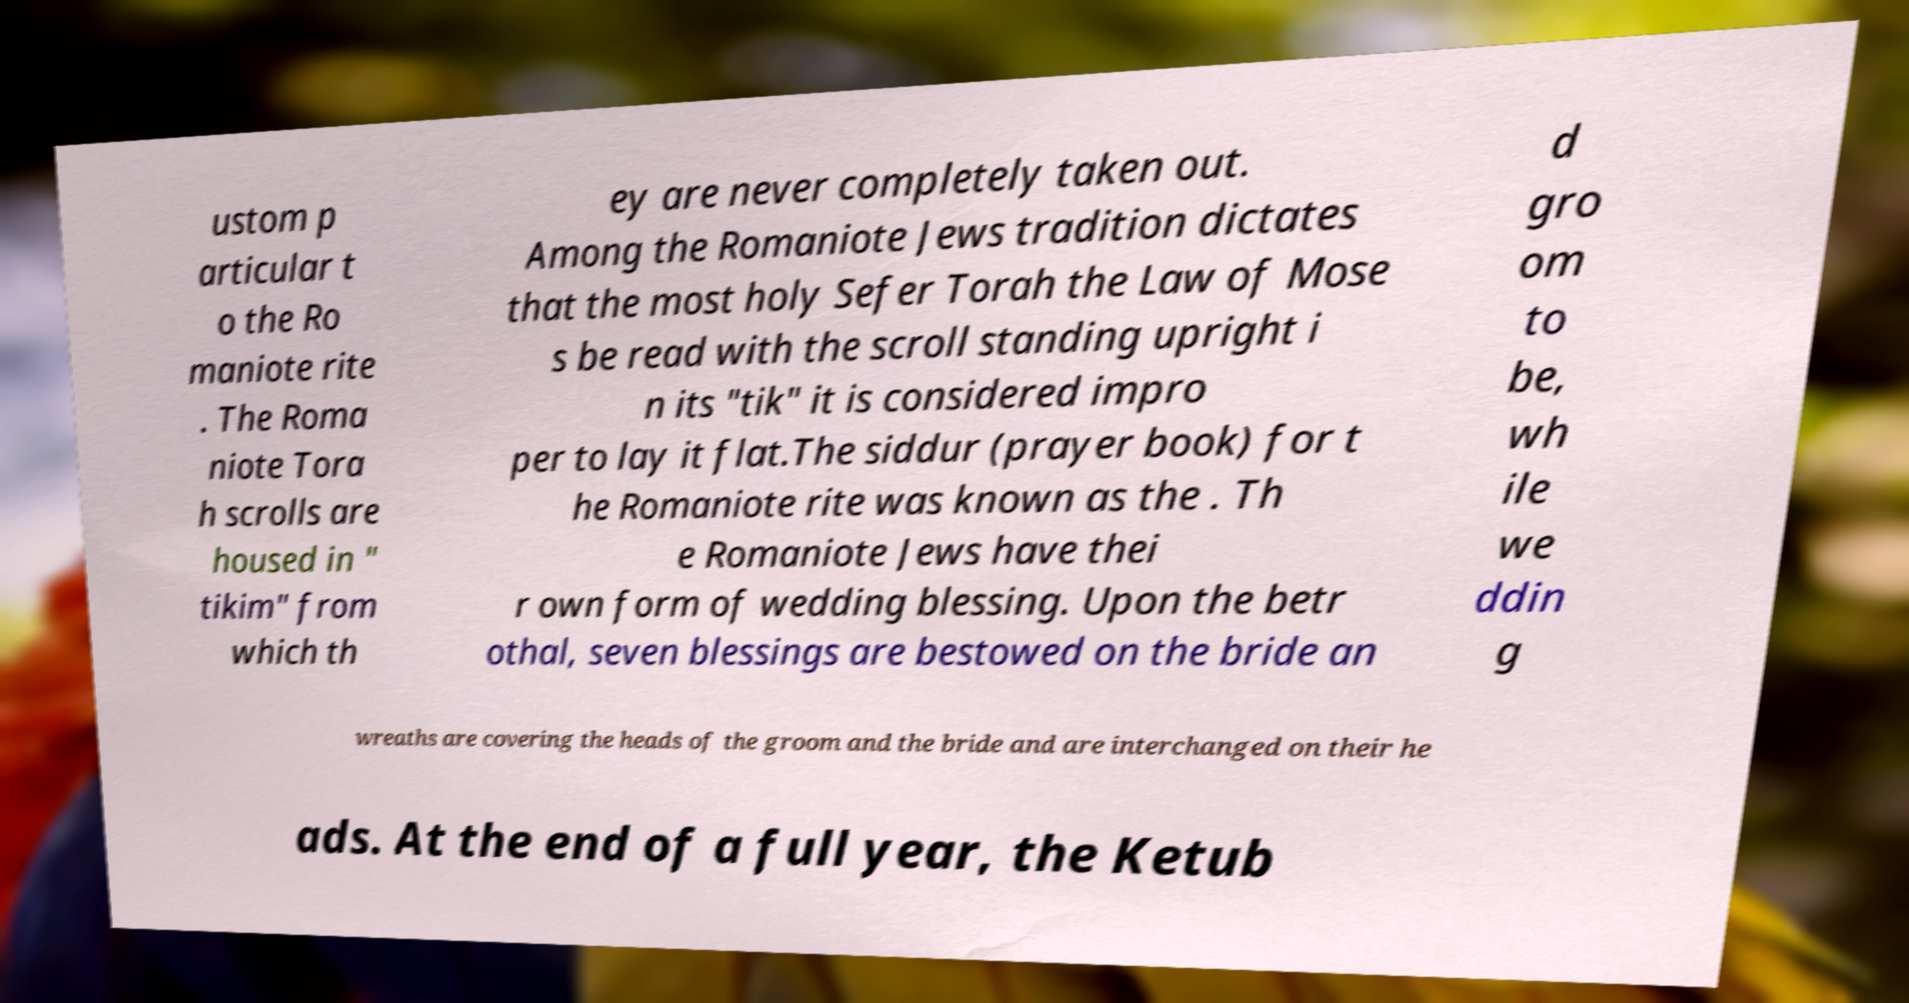I need the written content from this picture converted into text. Can you do that? ustom p articular t o the Ro maniote rite . The Roma niote Tora h scrolls are housed in " tikim" from which th ey are never completely taken out. Among the Romaniote Jews tradition dictates that the most holy Sefer Torah the Law of Mose s be read with the scroll standing upright i n its "tik" it is considered impro per to lay it flat.The siddur (prayer book) for t he Romaniote rite was known as the . Th e Romaniote Jews have thei r own form of wedding blessing. Upon the betr othal, seven blessings are bestowed on the bride an d gro om to be, wh ile we ddin g wreaths are covering the heads of the groom and the bride and are interchanged on their he ads. At the end of a full year, the Ketub 